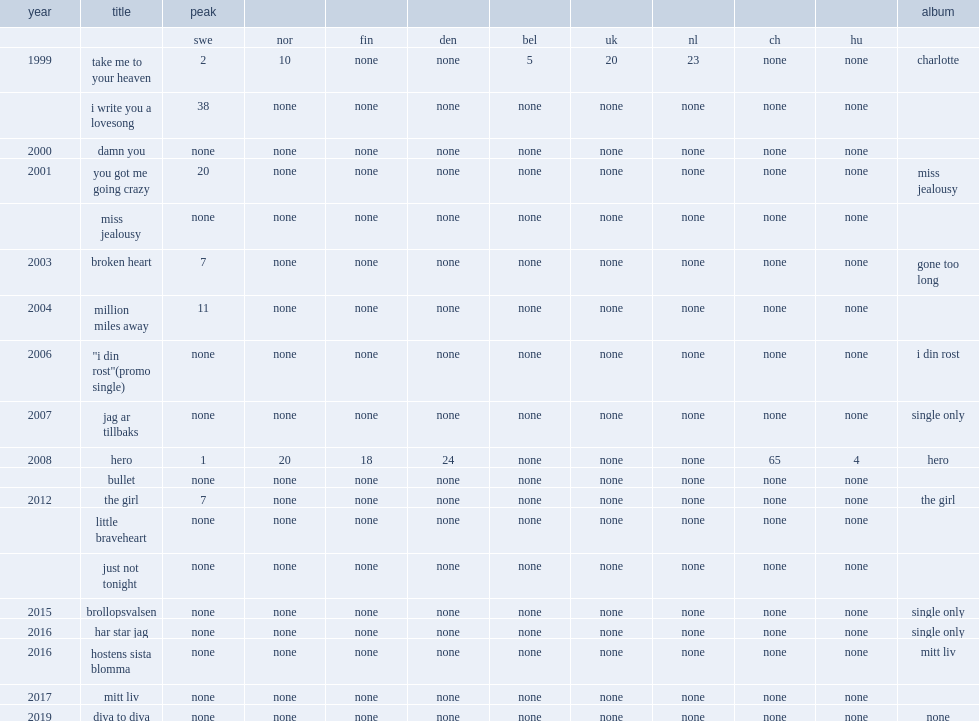Could you help me parse every detail presented in this table? {'header': ['year', 'title', 'peak', '', '', '', '', '', '', '', '', 'album'], 'rows': [['', '', 'swe', 'nor', 'fin', 'den', 'bel', 'uk', 'nl', 'ch', 'hu', ''], ['1999', 'take me to your heaven', '2', '10', 'none', 'none', '5', '20', '23', 'none', 'none', 'charlotte'], ['', 'i write you a lovesong', '38', 'none', 'none', 'none', 'none', 'none', 'none', 'none', 'none', ''], ['2000', 'damn you', 'none', 'none', 'none', 'none', 'none', 'none', 'none', 'none', 'none', ''], ['2001', 'you got me going crazy', '20', 'none', 'none', 'none', 'none', 'none', 'none', 'none', 'none', 'miss jealousy'], ['', 'miss jealousy', 'none', 'none', 'none', 'none', 'none', 'none', 'none', 'none', 'none', ''], ['2003', 'broken heart', '7', 'none', 'none', 'none', 'none', 'none', 'none', 'none', 'none', 'gone too long'], ['2004', 'million miles away', '11', 'none', 'none', 'none', 'none', 'none', 'none', 'none', 'none', ''], ['2006', '"i din rost"(promo single)', 'none', 'none', 'none', 'none', 'none', 'none', 'none', 'none', 'none', 'i din rost'], ['2007', 'jag ar tillbaks', 'none', 'none', 'none', 'none', 'none', 'none', 'none', 'none', 'none', 'single only'], ['2008', 'hero', '1', '20', '18', '24', 'none', 'none', 'none', '65', '4', 'hero'], ['', 'bullet', 'none', 'none', 'none', 'none', 'none', 'none', 'none', 'none', 'none', ''], ['2012', 'the girl', '7', 'none', 'none', 'none', 'none', 'none', 'none', 'none', 'none', 'the girl'], ['', 'little braveheart', 'none', 'none', 'none', 'none', 'none', 'none', 'none', 'none', 'none', ''], ['', 'just not tonight', 'none', 'none', 'none', 'none', 'none', 'none', 'none', 'none', 'none', ''], ['2015', 'brollopsvalsen', 'none', 'none', 'none', 'none', 'none', 'none', 'none', 'none', 'none', 'single only'], ['2016', 'har star jag', 'none', 'none', 'none', 'none', 'none', 'none', 'none', 'none', 'none', 'single only'], ['2016', 'hostens sista blomma', 'none', 'none', 'none', 'none', 'none', 'none', 'none', 'none', 'none', 'mitt liv'], ['2017', 'mitt liv', 'none', 'none', 'none', 'none', 'none', 'none', 'none', 'none', 'none', ''], ['2019', 'diva to diva', 'none', 'none', 'none', 'none', 'none', 'none', 'none', 'none', 'none', 'none']]} When did "the girl" release? 2012.0. 